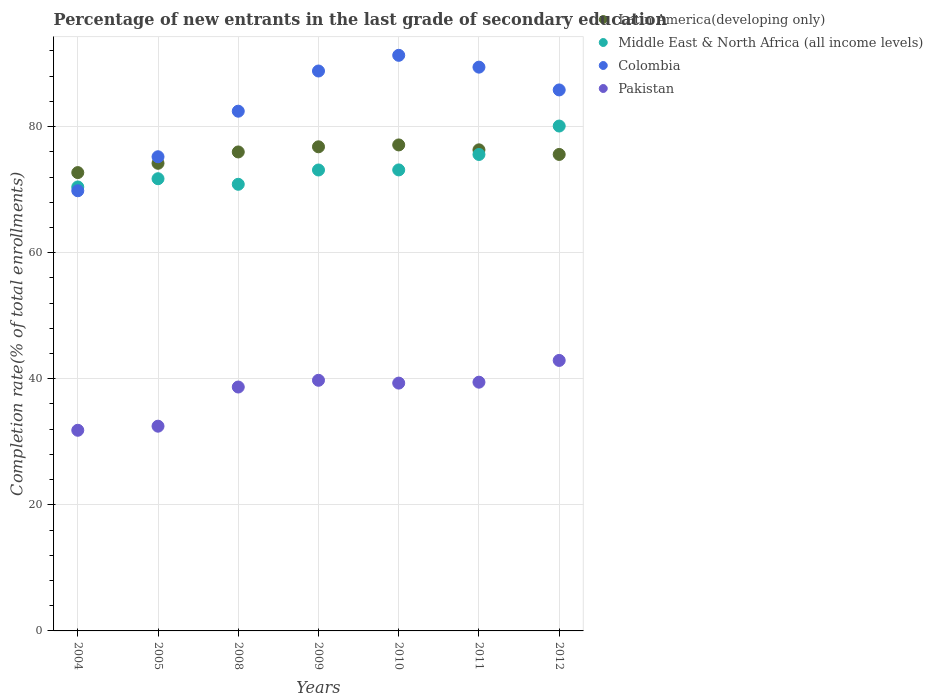How many different coloured dotlines are there?
Offer a very short reply. 4. Is the number of dotlines equal to the number of legend labels?
Keep it short and to the point. Yes. What is the percentage of new entrants in Latin America(developing only) in 2009?
Ensure brevity in your answer.  76.79. Across all years, what is the maximum percentage of new entrants in Middle East & North Africa (all income levels)?
Your response must be concise. 80.09. Across all years, what is the minimum percentage of new entrants in Colombia?
Offer a very short reply. 69.82. In which year was the percentage of new entrants in Latin America(developing only) maximum?
Keep it short and to the point. 2010. What is the total percentage of new entrants in Colombia in the graph?
Your answer should be very brief. 582.82. What is the difference between the percentage of new entrants in Colombia in 2005 and that in 2008?
Provide a short and direct response. -7.23. What is the difference between the percentage of new entrants in Colombia in 2009 and the percentage of new entrants in Middle East & North Africa (all income levels) in 2012?
Offer a very short reply. 8.73. What is the average percentage of new entrants in Colombia per year?
Provide a succinct answer. 83.26. In the year 2011, what is the difference between the percentage of new entrants in Latin America(developing only) and percentage of new entrants in Colombia?
Provide a short and direct response. -13.12. In how many years, is the percentage of new entrants in Colombia greater than 40 %?
Offer a terse response. 7. What is the ratio of the percentage of new entrants in Pakistan in 2004 to that in 2011?
Your answer should be very brief. 0.81. Is the percentage of new entrants in Pakistan in 2008 less than that in 2011?
Your response must be concise. Yes. Is the difference between the percentage of new entrants in Latin America(developing only) in 2008 and 2009 greater than the difference between the percentage of new entrants in Colombia in 2008 and 2009?
Keep it short and to the point. Yes. What is the difference between the highest and the second highest percentage of new entrants in Middle East & North Africa (all income levels)?
Offer a terse response. 4.51. What is the difference between the highest and the lowest percentage of new entrants in Colombia?
Ensure brevity in your answer.  21.48. Is the percentage of new entrants in Latin America(developing only) strictly greater than the percentage of new entrants in Colombia over the years?
Provide a succinct answer. No. Is the percentage of new entrants in Pakistan strictly less than the percentage of new entrants in Middle East & North Africa (all income levels) over the years?
Your response must be concise. Yes. How many dotlines are there?
Provide a succinct answer. 4. Does the graph contain grids?
Make the answer very short. Yes. How many legend labels are there?
Offer a very short reply. 4. What is the title of the graph?
Your response must be concise. Percentage of new entrants in the last grade of secondary education. What is the label or title of the Y-axis?
Your answer should be very brief. Completion rate(% of total enrollments). What is the Completion rate(% of total enrollments) of Latin America(developing only) in 2004?
Your answer should be compact. 72.7. What is the Completion rate(% of total enrollments) in Middle East & North Africa (all income levels) in 2004?
Make the answer very short. 70.42. What is the Completion rate(% of total enrollments) of Colombia in 2004?
Your answer should be very brief. 69.82. What is the Completion rate(% of total enrollments) of Pakistan in 2004?
Make the answer very short. 31.83. What is the Completion rate(% of total enrollments) of Latin America(developing only) in 2005?
Keep it short and to the point. 74.18. What is the Completion rate(% of total enrollments) in Middle East & North Africa (all income levels) in 2005?
Offer a very short reply. 71.73. What is the Completion rate(% of total enrollments) of Colombia in 2005?
Your answer should be very brief. 75.21. What is the Completion rate(% of total enrollments) in Pakistan in 2005?
Your answer should be very brief. 32.48. What is the Completion rate(% of total enrollments) of Latin America(developing only) in 2008?
Offer a terse response. 75.98. What is the Completion rate(% of total enrollments) in Middle East & North Africa (all income levels) in 2008?
Your response must be concise. 70.84. What is the Completion rate(% of total enrollments) in Colombia in 2008?
Provide a succinct answer. 82.44. What is the Completion rate(% of total enrollments) of Pakistan in 2008?
Your answer should be very brief. 38.69. What is the Completion rate(% of total enrollments) in Latin America(developing only) in 2009?
Provide a succinct answer. 76.79. What is the Completion rate(% of total enrollments) in Middle East & North Africa (all income levels) in 2009?
Your answer should be very brief. 73.11. What is the Completion rate(% of total enrollments) in Colombia in 2009?
Offer a terse response. 88.81. What is the Completion rate(% of total enrollments) of Pakistan in 2009?
Your answer should be very brief. 39.76. What is the Completion rate(% of total enrollments) of Latin America(developing only) in 2010?
Offer a very short reply. 77.09. What is the Completion rate(% of total enrollments) in Middle East & North Africa (all income levels) in 2010?
Your answer should be compact. 73.13. What is the Completion rate(% of total enrollments) in Colombia in 2010?
Provide a succinct answer. 91.3. What is the Completion rate(% of total enrollments) of Pakistan in 2010?
Offer a terse response. 39.31. What is the Completion rate(% of total enrollments) in Latin America(developing only) in 2011?
Your answer should be very brief. 76.31. What is the Completion rate(% of total enrollments) in Middle East & North Africa (all income levels) in 2011?
Provide a succinct answer. 75.57. What is the Completion rate(% of total enrollments) of Colombia in 2011?
Make the answer very short. 89.43. What is the Completion rate(% of total enrollments) of Pakistan in 2011?
Your response must be concise. 39.45. What is the Completion rate(% of total enrollments) of Latin America(developing only) in 2012?
Give a very brief answer. 75.58. What is the Completion rate(% of total enrollments) in Middle East & North Africa (all income levels) in 2012?
Offer a very short reply. 80.09. What is the Completion rate(% of total enrollments) of Colombia in 2012?
Your response must be concise. 85.81. What is the Completion rate(% of total enrollments) in Pakistan in 2012?
Give a very brief answer. 42.91. Across all years, what is the maximum Completion rate(% of total enrollments) of Latin America(developing only)?
Offer a terse response. 77.09. Across all years, what is the maximum Completion rate(% of total enrollments) of Middle East & North Africa (all income levels)?
Your answer should be compact. 80.09. Across all years, what is the maximum Completion rate(% of total enrollments) in Colombia?
Offer a terse response. 91.3. Across all years, what is the maximum Completion rate(% of total enrollments) of Pakistan?
Make the answer very short. 42.91. Across all years, what is the minimum Completion rate(% of total enrollments) of Latin America(developing only)?
Your response must be concise. 72.7. Across all years, what is the minimum Completion rate(% of total enrollments) in Middle East & North Africa (all income levels)?
Provide a succinct answer. 70.42. Across all years, what is the minimum Completion rate(% of total enrollments) of Colombia?
Ensure brevity in your answer.  69.82. Across all years, what is the minimum Completion rate(% of total enrollments) in Pakistan?
Offer a terse response. 31.83. What is the total Completion rate(% of total enrollments) of Latin America(developing only) in the graph?
Give a very brief answer. 528.62. What is the total Completion rate(% of total enrollments) of Middle East & North Africa (all income levels) in the graph?
Provide a short and direct response. 514.89. What is the total Completion rate(% of total enrollments) in Colombia in the graph?
Offer a terse response. 582.82. What is the total Completion rate(% of total enrollments) of Pakistan in the graph?
Your answer should be compact. 264.42. What is the difference between the Completion rate(% of total enrollments) of Latin America(developing only) in 2004 and that in 2005?
Ensure brevity in your answer.  -1.48. What is the difference between the Completion rate(% of total enrollments) of Middle East & North Africa (all income levels) in 2004 and that in 2005?
Keep it short and to the point. -1.31. What is the difference between the Completion rate(% of total enrollments) of Colombia in 2004 and that in 2005?
Your answer should be very brief. -5.39. What is the difference between the Completion rate(% of total enrollments) in Pakistan in 2004 and that in 2005?
Give a very brief answer. -0.65. What is the difference between the Completion rate(% of total enrollments) in Latin America(developing only) in 2004 and that in 2008?
Your response must be concise. -3.27. What is the difference between the Completion rate(% of total enrollments) in Middle East & North Africa (all income levels) in 2004 and that in 2008?
Provide a short and direct response. -0.42. What is the difference between the Completion rate(% of total enrollments) of Colombia in 2004 and that in 2008?
Ensure brevity in your answer.  -12.62. What is the difference between the Completion rate(% of total enrollments) in Pakistan in 2004 and that in 2008?
Offer a terse response. -6.86. What is the difference between the Completion rate(% of total enrollments) in Latin America(developing only) in 2004 and that in 2009?
Your answer should be very brief. -4.09. What is the difference between the Completion rate(% of total enrollments) of Middle East & North Africa (all income levels) in 2004 and that in 2009?
Give a very brief answer. -2.69. What is the difference between the Completion rate(% of total enrollments) of Colombia in 2004 and that in 2009?
Offer a very short reply. -18.99. What is the difference between the Completion rate(% of total enrollments) in Pakistan in 2004 and that in 2009?
Provide a short and direct response. -7.93. What is the difference between the Completion rate(% of total enrollments) of Latin America(developing only) in 2004 and that in 2010?
Your answer should be compact. -4.39. What is the difference between the Completion rate(% of total enrollments) of Middle East & North Africa (all income levels) in 2004 and that in 2010?
Offer a terse response. -2.7. What is the difference between the Completion rate(% of total enrollments) of Colombia in 2004 and that in 2010?
Offer a terse response. -21.48. What is the difference between the Completion rate(% of total enrollments) in Pakistan in 2004 and that in 2010?
Ensure brevity in your answer.  -7.48. What is the difference between the Completion rate(% of total enrollments) in Latin America(developing only) in 2004 and that in 2011?
Provide a short and direct response. -3.61. What is the difference between the Completion rate(% of total enrollments) of Middle East & North Africa (all income levels) in 2004 and that in 2011?
Your response must be concise. -5.15. What is the difference between the Completion rate(% of total enrollments) of Colombia in 2004 and that in 2011?
Your answer should be very brief. -19.61. What is the difference between the Completion rate(% of total enrollments) of Pakistan in 2004 and that in 2011?
Your answer should be very brief. -7.63. What is the difference between the Completion rate(% of total enrollments) of Latin America(developing only) in 2004 and that in 2012?
Ensure brevity in your answer.  -2.88. What is the difference between the Completion rate(% of total enrollments) in Middle East & North Africa (all income levels) in 2004 and that in 2012?
Keep it short and to the point. -9.66. What is the difference between the Completion rate(% of total enrollments) of Colombia in 2004 and that in 2012?
Your response must be concise. -15.99. What is the difference between the Completion rate(% of total enrollments) of Pakistan in 2004 and that in 2012?
Offer a very short reply. -11.08. What is the difference between the Completion rate(% of total enrollments) of Latin America(developing only) in 2005 and that in 2008?
Give a very brief answer. -1.8. What is the difference between the Completion rate(% of total enrollments) of Middle East & North Africa (all income levels) in 2005 and that in 2008?
Your response must be concise. 0.88. What is the difference between the Completion rate(% of total enrollments) in Colombia in 2005 and that in 2008?
Give a very brief answer. -7.23. What is the difference between the Completion rate(% of total enrollments) of Pakistan in 2005 and that in 2008?
Make the answer very short. -6.21. What is the difference between the Completion rate(% of total enrollments) of Latin America(developing only) in 2005 and that in 2009?
Offer a very short reply. -2.61. What is the difference between the Completion rate(% of total enrollments) in Middle East & North Africa (all income levels) in 2005 and that in 2009?
Your answer should be compact. -1.38. What is the difference between the Completion rate(% of total enrollments) in Colombia in 2005 and that in 2009?
Keep it short and to the point. -13.6. What is the difference between the Completion rate(% of total enrollments) in Pakistan in 2005 and that in 2009?
Provide a succinct answer. -7.28. What is the difference between the Completion rate(% of total enrollments) in Latin America(developing only) in 2005 and that in 2010?
Your answer should be compact. -2.91. What is the difference between the Completion rate(% of total enrollments) of Middle East & North Africa (all income levels) in 2005 and that in 2010?
Give a very brief answer. -1.4. What is the difference between the Completion rate(% of total enrollments) in Colombia in 2005 and that in 2010?
Your answer should be compact. -16.09. What is the difference between the Completion rate(% of total enrollments) in Pakistan in 2005 and that in 2010?
Your answer should be very brief. -6.83. What is the difference between the Completion rate(% of total enrollments) of Latin America(developing only) in 2005 and that in 2011?
Your response must be concise. -2.13. What is the difference between the Completion rate(% of total enrollments) of Middle East & North Africa (all income levels) in 2005 and that in 2011?
Provide a short and direct response. -3.85. What is the difference between the Completion rate(% of total enrollments) in Colombia in 2005 and that in 2011?
Your response must be concise. -14.21. What is the difference between the Completion rate(% of total enrollments) in Pakistan in 2005 and that in 2011?
Provide a succinct answer. -6.98. What is the difference between the Completion rate(% of total enrollments) of Latin America(developing only) in 2005 and that in 2012?
Your answer should be very brief. -1.41. What is the difference between the Completion rate(% of total enrollments) of Middle East & North Africa (all income levels) in 2005 and that in 2012?
Give a very brief answer. -8.36. What is the difference between the Completion rate(% of total enrollments) of Colombia in 2005 and that in 2012?
Make the answer very short. -10.6. What is the difference between the Completion rate(% of total enrollments) of Pakistan in 2005 and that in 2012?
Your answer should be compact. -10.43. What is the difference between the Completion rate(% of total enrollments) of Latin America(developing only) in 2008 and that in 2009?
Ensure brevity in your answer.  -0.82. What is the difference between the Completion rate(% of total enrollments) of Middle East & North Africa (all income levels) in 2008 and that in 2009?
Offer a very short reply. -2.27. What is the difference between the Completion rate(% of total enrollments) of Colombia in 2008 and that in 2009?
Offer a terse response. -6.37. What is the difference between the Completion rate(% of total enrollments) of Pakistan in 2008 and that in 2009?
Offer a terse response. -1.07. What is the difference between the Completion rate(% of total enrollments) of Latin America(developing only) in 2008 and that in 2010?
Give a very brief answer. -1.11. What is the difference between the Completion rate(% of total enrollments) of Middle East & North Africa (all income levels) in 2008 and that in 2010?
Offer a very short reply. -2.28. What is the difference between the Completion rate(% of total enrollments) of Colombia in 2008 and that in 2010?
Provide a succinct answer. -8.86. What is the difference between the Completion rate(% of total enrollments) of Pakistan in 2008 and that in 2010?
Your response must be concise. -0.62. What is the difference between the Completion rate(% of total enrollments) in Latin America(developing only) in 2008 and that in 2011?
Provide a succinct answer. -0.34. What is the difference between the Completion rate(% of total enrollments) in Middle East & North Africa (all income levels) in 2008 and that in 2011?
Provide a short and direct response. -4.73. What is the difference between the Completion rate(% of total enrollments) in Colombia in 2008 and that in 2011?
Ensure brevity in your answer.  -6.99. What is the difference between the Completion rate(% of total enrollments) of Pakistan in 2008 and that in 2011?
Offer a terse response. -0.77. What is the difference between the Completion rate(% of total enrollments) of Latin America(developing only) in 2008 and that in 2012?
Your answer should be compact. 0.39. What is the difference between the Completion rate(% of total enrollments) in Middle East & North Africa (all income levels) in 2008 and that in 2012?
Make the answer very short. -9.24. What is the difference between the Completion rate(% of total enrollments) of Colombia in 2008 and that in 2012?
Keep it short and to the point. -3.37. What is the difference between the Completion rate(% of total enrollments) of Pakistan in 2008 and that in 2012?
Make the answer very short. -4.22. What is the difference between the Completion rate(% of total enrollments) of Latin America(developing only) in 2009 and that in 2010?
Keep it short and to the point. -0.3. What is the difference between the Completion rate(% of total enrollments) of Middle East & North Africa (all income levels) in 2009 and that in 2010?
Offer a terse response. -0.01. What is the difference between the Completion rate(% of total enrollments) of Colombia in 2009 and that in 2010?
Keep it short and to the point. -2.49. What is the difference between the Completion rate(% of total enrollments) of Pakistan in 2009 and that in 2010?
Provide a succinct answer. 0.45. What is the difference between the Completion rate(% of total enrollments) of Latin America(developing only) in 2009 and that in 2011?
Ensure brevity in your answer.  0.48. What is the difference between the Completion rate(% of total enrollments) of Middle East & North Africa (all income levels) in 2009 and that in 2011?
Offer a terse response. -2.46. What is the difference between the Completion rate(% of total enrollments) of Colombia in 2009 and that in 2011?
Your response must be concise. -0.61. What is the difference between the Completion rate(% of total enrollments) in Pakistan in 2009 and that in 2011?
Your answer should be very brief. 0.3. What is the difference between the Completion rate(% of total enrollments) in Latin America(developing only) in 2009 and that in 2012?
Your answer should be very brief. 1.21. What is the difference between the Completion rate(% of total enrollments) in Middle East & North Africa (all income levels) in 2009 and that in 2012?
Provide a short and direct response. -6.97. What is the difference between the Completion rate(% of total enrollments) of Colombia in 2009 and that in 2012?
Provide a succinct answer. 3. What is the difference between the Completion rate(% of total enrollments) of Pakistan in 2009 and that in 2012?
Your answer should be compact. -3.15. What is the difference between the Completion rate(% of total enrollments) in Latin America(developing only) in 2010 and that in 2011?
Make the answer very short. 0.78. What is the difference between the Completion rate(% of total enrollments) of Middle East & North Africa (all income levels) in 2010 and that in 2011?
Offer a terse response. -2.45. What is the difference between the Completion rate(% of total enrollments) in Colombia in 2010 and that in 2011?
Make the answer very short. 1.88. What is the difference between the Completion rate(% of total enrollments) of Pakistan in 2010 and that in 2011?
Make the answer very short. -0.14. What is the difference between the Completion rate(% of total enrollments) of Latin America(developing only) in 2010 and that in 2012?
Make the answer very short. 1.51. What is the difference between the Completion rate(% of total enrollments) in Middle East & North Africa (all income levels) in 2010 and that in 2012?
Provide a short and direct response. -6.96. What is the difference between the Completion rate(% of total enrollments) in Colombia in 2010 and that in 2012?
Your response must be concise. 5.49. What is the difference between the Completion rate(% of total enrollments) in Pakistan in 2010 and that in 2012?
Keep it short and to the point. -3.6. What is the difference between the Completion rate(% of total enrollments) of Latin America(developing only) in 2011 and that in 2012?
Offer a terse response. 0.73. What is the difference between the Completion rate(% of total enrollments) of Middle East & North Africa (all income levels) in 2011 and that in 2012?
Your answer should be compact. -4.51. What is the difference between the Completion rate(% of total enrollments) of Colombia in 2011 and that in 2012?
Offer a very short reply. 3.61. What is the difference between the Completion rate(% of total enrollments) of Pakistan in 2011 and that in 2012?
Offer a terse response. -3.45. What is the difference between the Completion rate(% of total enrollments) in Latin America(developing only) in 2004 and the Completion rate(% of total enrollments) in Middle East & North Africa (all income levels) in 2005?
Offer a terse response. 0.97. What is the difference between the Completion rate(% of total enrollments) in Latin America(developing only) in 2004 and the Completion rate(% of total enrollments) in Colombia in 2005?
Give a very brief answer. -2.51. What is the difference between the Completion rate(% of total enrollments) of Latin America(developing only) in 2004 and the Completion rate(% of total enrollments) of Pakistan in 2005?
Your response must be concise. 40.22. What is the difference between the Completion rate(% of total enrollments) of Middle East & North Africa (all income levels) in 2004 and the Completion rate(% of total enrollments) of Colombia in 2005?
Give a very brief answer. -4.79. What is the difference between the Completion rate(% of total enrollments) of Middle East & North Africa (all income levels) in 2004 and the Completion rate(% of total enrollments) of Pakistan in 2005?
Your response must be concise. 37.95. What is the difference between the Completion rate(% of total enrollments) in Colombia in 2004 and the Completion rate(% of total enrollments) in Pakistan in 2005?
Ensure brevity in your answer.  37.34. What is the difference between the Completion rate(% of total enrollments) in Latin America(developing only) in 2004 and the Completion rate(% of total enrollments) in Middle East & North Africa (all income levels) in 2008?
Keep it short and to the point. 1.86. What is the difference between the Completion rate(% of total enrollments) in Latin America(developing only) in 2004 and the Completion rate(% of total enrollments) in Colombia in 2008?
Provide a short and direct response. -9.74. What is the difference between the Completion rate(% of total enrollments) in Latin America(developing only) in 2004 and the Completion rate(% of total enrollments) in Pakistan in 2008?
Ensure brevity in your answer.  34.01. What is the difference between the Completion rate(% of total enrollments) of Middle East & North Africa (all income levels) in 2004 and the Completion rate(% of total enrollments) of Colombia in 2008?
Provide a succinct answer. -12.02. What is the difference between the Completion rate(% of total enrollments) of Middle East & North Africa (all income levels) in 2004 and the Completion rate(% of total enrollments) of Pakistan in 2008?
Ensure brevity in your answer.  31.73. What is the difference between the Completion rate(% of total enrollments) of Colombia in 2004 and the Completion rate(% of total enrollments) of Pakistan in 2008?
Give a very brief answer. 31.13. What is the difference between the Completion rate(% of total enrollments) of Latin America(developing only) in 2004 and the Completion rate(% of total enrollments) of Middle East & North Africa (all income levels) in 2009?
Offer a terse response. -0.41. What is the difference between the Completion rate(% of total enrollments) of Latin America(developing only) in 2004 and the Completion rate(% of total enrollments) of Colombia in 2009?
Offer a terse response. -16.11. What is the difference between the Completion rate(% of total enrollments) in Latin America(developing only) in 2004 and the Completion rate(% of total enrollments) in Pakistan in 2009?
Keep it short and to the point. 32.94. What is the difference between the Completion rate(% of total enrollments) of Middle East & North Africa (all income levels) in 2004 and the Completion rate(% of total enrollments) of Colombia in 2009?
Your answer should be compact. -18.39. What is the difference between the Completion rate(% of total enrollments) of Middle East & North Africa (all income levels) in 2004 and the Completion rate(% of total enrollments) of Pakistan in 2009?
Make the answer very short. 30.66. What is the difference between the Completion rate(% of total enrollments) of Colombia in 2004 and the Completion rate(% of total enrollments) of Pakistan in 2009?
Your answer should be compact. 30.06. What is the difference between the Completion rate(% of total enrollments) in Latin America(developing only) in 2004 and the Completion rate(% of total enrollments) in Middle East & North Africa (all income levels) in 2010?
Your answer should be very brief. -0.42. What is the difference between the Completion rate(% of total enrollments) of Latin America(developing only) in 2004 and the Completion rate(% of total enrollments) of Colombia in 2010?
Give a very brief answer. -18.6. What is the difference between the Completion rate(% of total enrollments) of Latin America(developing only) in 2004 and the Completion rate(% of total enrollments) of Pakistan in 2010?
Offer a very short reply. 33.39. What is the difference between the Completion rate(% of total enrollments) of Middle East & North Africa (all income levels) in 2004 and the Completion rate(% of total enrollments) of Colombia in 2010?
Keep it short and to the point. -20.88. What is the difference between the Completion rate(% of total enrollments) of Middle East & North Africa (all income levels) in 2004 and the Completion rate(% of total enrollments) of Pakistan in 2010?
Offer a very short reply. 31.11. What is the difference between the Completion rate(% of total enrollments) of Colombia in 2004 and the Completion rate(% of total enrollments) of Pakistan in 2010?
Provide a short and direct response. 30.51. What is the difference between the Completion rate(% of total enrollments) in Latin America(developing only) in 2004 and the Completion rate(% of total enrollments) in Middle East & North Africa (all income levels) in 2011?
Keep it short and to the point. -2.87. What is the difference between the Completion rate(% of total enrollments) of Latin America(developing only) in 2004 and the Completion rate(% of total enrollments) of Colombia in 2011?
Offer a terse response. -16.73. What is the difference between the Completion rate(% of total enrollments) of Latin America(developing only) in 2004 and the Completion rate(% of total enrollments) of Pakistan in 2011?
Your response must be concise. 33.25. What is the difference between the Completion rate(% of total enrollments) in Middle East & North Africa (all income levels) in 2004 and the Completion rate(% of total enrollments) in Colombia in 2011?
Your answer should be very brief. -19. What is the difference between the Completion rate(% of total enrollments) of Middle East & North Africa (all income levels) in 2004 and the Completion rate(% of total enrollments) of Pakistan in 2011?
Make the answer very short. 30.97. What is the difference between the Completion rate(% of total enrollments) in Colombia in 2004 and the Completion rate(% of total enrollments) in Pakistan in 2011?
Provide a succinct answer. 30.36. What is the difference between the Completion rate(% of total enrollments) in Latin America(developing only) in 2004 and the Completion rate(% of total enrollments) in Middle East & North Africa (all income levels) in 2012?
Keep it short and to the point. -7.38. What is the difference between the Completion rate(% of total enrollments) of Latin America(developing only) in 2004 and the Completion rate(% of total enrollments) of Colombia in 2012?
Provide a short and direct response. -13.11. What is the difference between the Completion rate(% of total enrollments) in Latin America(developing only) in 2004 and the Completion rate(% of total enrollments) in Pakistan in 2012?
Make the answer very short. 29.79. What is the difference between the Completion rate(% of total enrollments) in Middle East & North Africa (all income levels) in 2004 and the Completion rate(% of total enrollments) in Colombia in 2012?
Offer a very short reply. -15.39. What is the difference between the Completion rate(% of total enrollments) of Middle East & North Africa (all income levels) in 2004 and the Completion rate(% of total enrollments) of Pakistan in 2012?
Provide a short and direct response. 27.52. What is the difference between the Completion rate(% of total enrollments) in Colombia in 2004 and the Completion rate(% of total enrollments) in Pakistan in 2012?
Give a very brief answer. 26.91. What is the difference between the Completion rate(% of total enrollments) of Latin America(developing only) in 2005 and the Completion rate(% of total enrollments) of Middle East & North Africa (all income levels) in 2008?
Your response must be concise. 3.33. What is the difference between the Completion rate(% of total enrollments) of Latin America(developing only) in 2005 and the Completion rate(% of total enrollments) of Colombia in 2008?
Offer a very short reply. -8.26. What is the difference between the Completion rate(% of total enrollments) of Latin America(developing only) in 2005 and the Completion rate(% of total enrollments) of Pakistan in 2008?
Provide a short and direct response. 35.49. What is the difference between the Completion rate(% of total enrollments) in Middle East & North Africa (all income levels) in 2005 and the Completion rate(% of total enrollments) in Colombia in 2008?
Offer a terse response. -10.71. What is the difference between the Completion rate(% of total enrollments) of Middle East & North Africa (all income levels) in 2005 and the Completion rate(% of total enrollments) of Pakistan in 2008?
Provide a succinct answer. 33.04. What is the difference between the Completion rate(% of total enrollments) in Colombia in 2005 and the Completion rate(% of total enrollments) in Pakistan in 2008?
Your answer should be very brief. 36.52. What is the difference between the Completion rate(% of total enrollments) in Latin America(developing only) in 2005 and the Completion rate(% of total enrollments) in Middle East & North Africa (all income levels) in 2009?
Keep it short and to the point. 1.06. What is the difference between the Completion rate(% of total enrollments) of Latin America(developing only) in 2005 and the Completion rate(% of total enrollments) of Colombia in 2009?
Ensure brevity in your answer.  -14.64. What is the difference between the Completion rate(% of total enrollments) in Latin America(developing only) in 2005 and the Completion rate(% of total enrollments) in Pakistan in 2009?
Provide a succinct answer. 34.42. What is the difference between the Completion rate(% of total enrollments) in Middle East & North Africa (all income levels) in 2005 and the Completion rate(% of total enrollments) in Colombia in 2009?
Provide a succinct answer. -17.09. What is the difference between the Completion rate(% of total enrollments) in Middle East & North Africa (all income levels) in 2005 and the Completion rate(% of total enrollments) in Pakistan in 2009?
Offer a very short reply. 31.97. What is the difference between the Completion rate(% of total enrollments) of Colombia in 2005 and the Completion rate(% of total enrollments) of Pakistan in 2009?
Offer a very short reply. 35.46. What is the difference between the Completion rate(% of total enrollments) of Latin America(developing only) in 2005 and the Completion rate(% of total enrollments) of Middle East & North Africa (all income levels) in 2010?
Provide a short and direct response. 1.05. What is the difference between the Completion rate(% of total enrollments) of Latin America(developing only) in 2005 and the Completion rate(% of total enrollments) of Colombia in 2010?
Offer a terse response. -17.13. What is the difference between the Completion rate(% of total enrollments) in Latin America(developing only) in 2005 and the Completion rate(% of total enrollments) in Pakistan in 2010?
Your response must be concise. 34.87. What is the difference between the Completion rate(% of total enrollments) of Middle East & North Africa (all income levels) in 2005 and the Completion rate(% of total enrollments) of Colombia in 2010?
Ensure brevity in your answer.  -19.57. What is the difference between the Completion rate(% of total enrollments) in Middle East & North Africa (all income levels) in 2005 and the Completion rate(% of total enrollments) in Pakistan in 2010?
Your answer should be compact. 32.42. What is the difference between the Completion rate(% of total enrollments) in Colombia in 2005 and the Completion rate(% of total enrollments) in Pakistan in 2010?
Your response must be concise. 35.9. What is the difference between the Completion rate(% of total enrollments) in Latin America(developing only) in 2005 and the Completion rate(% of total enrollments) in Middle East & North Africa (all income levels) in 2011?
Offer a very short reply. -1.4. What is the difference between the Completion rate(% of total enrollments) of Latin America(developing only) in 2005 and the Completion rate(% of total enrollments) of Colombia in 2011?
Ensure brevity in your answer.  -15.25. What is the difference between the Completion rate(% of total enrollments) in Latin America(developing only) in 2005 and the Completion rate(% of total enrollments) in Pakistan in 2011?
Provide a succinct answer. 34.72. What is the difference between the Completion rate(% of total enrollments) in Middle East & North Africa (all income levels) in 2005 and the Completion rate(% of total enrollments) in Colombia in 2011?
Ensure brevity in your answer.  -17.7. What is the difference between the Completion rate(% of total enrollments) of Middle East & North Africa (all income levels) in 2005 and the Completion rate(% of total enrollments) of Pakistan in 2011?
Make the answer very short. 32.27. What is the difference between the Completion rate(% of total enrollments) in Colombia in 2005 and the Completion rate(% of total enrollments) in Pakistan in 2011?
Give a very brief answer. 35.76. What is the difference between the Completion rate(% of total enrollments) in Latin America(developing only) in 2005 and the Completion rate(% of total enrollments) in Middle East & North Africa (all income levels) in 2012?
Offer a very short reply. -5.91. What is the difference between the Completion rate(% of total enrollments) in Latin America(developing only) in 2005 and the Completion rate(% of total enrollments) in Colombia in 2012?
Make the answer very short. -11.64. What is the difference between the Completion rate(% of total enrollments) of Latin America(developing only) in 2005 and the Completion rate(% of total enrollments) of Pakistan in 2012?
Offer a very short reply. 31.27. What is the difference between the Completion rate(% of total enrollments) of Middle East & North Africa (all income levels) in 2005 and the Completion rate(% of total enrollments) of Colombia in 2012?
Make the answer very short. -14.08. What is the difference between the Completion rate(% of total enrollments) in Middle East & North Africa (all income levels) in 2005 and the Completion rate(% of total enrollments) in Pakistan in 2012?
Offer a terse response. 28.82. What is the difference between the Completion rate(% of total enrollments) in Colombia in 2005 and the Completion rate(% of total enrollments) in Pakistan in 2012?
Your answer should be compact. 32.31. What is the difference between the Completion rate(% of total enrollments) of Latin America(developing only) in 2008 and the Completion rate(% of total enrollments) of Middle East & North Africa (all income levels) in 2009?
Keep it short and to the point. 2.86. What is the difference between the Completion rate(% of total enrollments) of Latin America(developing only) in 2008 and the Completion rate(% of total enrollments) of Colombia in 2009?
Offer a terse response. -12.84. What is the difference between the Completion rate(% of total enrollments) in Latin America(developing only) in 2008 and the Completion rate(% of total enrollments) in Pakistan in 2009?
Provide a short and direct response. 36.22. What is the difference between the Completion rate(% of total enrollments) in Middle East & North Africa (all income levels) in 2008 and the Completion rate(% of total enrollments) in Colombia in 2009?
Make the answer very short. -17.97. What is the difference between the Completion rate(% of total enrollments) in Middle East & North Africa (all income levels) in 2008 and the Completion rate(% of total enrollments) in Pakistan in 2009?
Keep it short and to the point. 31.09. What is the difference between the Completion rate(% of total enrollments) of Colombia in 2008 and the Completion rate(% of total enrollments) of Pakistan in 2009?
Your answer should be very brief. 42.68. What is the difference between the Completion rate(% of total enrollments) in Latin America(developing only) in 2008 and the Completion rate(% of total enrollments) in Middle East & North Africa (all income levels) in 2010?
Offer a very short reply. 2.85. What is the difference between the Completion rate(% of total enrollments) of Latin America(developing only) in 2008 and the Completion rate(% of total enrollments) of Colombia in 2010?
Give a very brief answer. -15.33. What is the difference between the Completion rate(% of total enrollments) in Latin America(developing only) in 2008 and the Completion rate(% of total enrollments) in Pakistan in 2010?
Offer a terse response. 36.67. What is the difference between the Completion rate(% of total enrollments) of Middle East & North Africa (all income levels) in 2008 and the Completion rate(% of total enrollments) of Colombia in 2010?
Keep it short and to the point. -20.46. What is the difference between the Completion rate(% of total enrollments) in Middle East & North Africa (all income levels) in 2008 and the Completion rate(% of total enrollments) in Pakistan in 2010?
Your response must be concise. 31.53. What is the difference between the Completion rate(% of total enrollments) in Colombia in 2008 and the Completion rate(% of total enrollments) in Pakistan in 2010?
Offer a terse response. 43.13. What is the difference between the Completion rate(% of total enrollments) in Latin America(developing only) in 2008 and the Completion rate(% of total enrollments) in Middle East & North Africa (all income levels) in 2011?
Provide a short and direct response. 0.4. What is the difference between the Completion rate(% of total enrollments) in Latin America(developing only) in 2008 and the Completion rate(% of total enrollments) in Colombia in 2011?
Make the answer very short. -13.45. What is the difference between the Completion rate(% of total enrollments) in Latin America(developing only) in 2008 and the Completion rate(% of total enrollments) in Pakistan in 2011?
Ensure brevity in your answer.  36.52. What is the difference between the Completion rate(% of total enrollments) of Middle East & North Africa (all income levels) in 2008 and the Completion rate(% of total enrollments) of Colombia in 2011?
Your answer should be very brief. -18.58. What is the difference between the Completion rate(% of total enrollments) of Middle East & North Africa (all income levels) in 2008 and the Completion rate(% of total enrollments) of Pakistan in 2011?
Offer a terse response. 31.39. What is the difference between the Completion rate(% of total enrollments) of Colombia in 2008 and the Completion rate(% of total enrollments) of Pakistan in 2011?
Offer a terse response. 42.98. What is the difference between the Completion rate(% of total enrollments) of Latin America(developing only) in 2008 and the Completion rate(% of total enrollments) of Middle East & North Africa (all income levels) in 2012?
Give a very brief answer. -4.11. What is the difference between the Completion rate(% of total enrollments) in Latin America(developing only) in 2008 and the Completion rate(% of total enrollments) in Colombia in 2012?
Provide a short and direct response. -9.84. What is the difference between the Completion rate(% of total enrollments) in Latin America(developing only) in 2008 and the Completion rate(% of total enrollments) in Pakistan in 2012?
Ensure brevity in your answer.  33.07. What is the difference between the Completion rate(% of total enrollments) of Middle East & North Africa (all income levels) in 2008 and the Completion rate(% of total enrollments) of Colombia in 2012?
Offer a very short reply. -14.97. What is the difference between the Completion rate(% of total enrollments) of Middle East & North Africa (all income levels) in 2008 and the Completion rate(% of total enrollments) of Pakistan in 2012?
Offer a very short reply. 27.94. What is the difference between the Completion rate(% of total enrollments) in Colombia in 2008 and the Completion rate(% of total enrollments) in Pakistan in 2012?
Give a very brief answer. 39.53. What is the difference between the Completion rate(% of total enrollments) in Latin America(developing only) in 2009 and the Completion rate(% of total enrollments) in Middle East & North Africa (all income levels) in 2010?
Your response must be concise. 3.66. What is the difference between the Completion rate(% of total enrollments) of Latin America(developing only) in 2009 and the Completion rate(% of total enrollments) of Colombia in 2010?
Your answer should be very brief. -14.51. What is the difference between the Completion rate(% of total enrollments) of Latin America(developing only) in 2009 and the Completion rate(% of total enrollments) of Pakistan in 2010?
Offer a terse response. 37.48. What is the difference between the Completion rate(% of total enrollments) of Middle East & North Africa (all income levels) in 2009 and the Completion rate(% of total enrollments) of Colombia in 2010?
Give a very brief answer. -18.19. What is the difference between the Completion rate(% of total enrollments) of Middle East & North Africa (all income levels) in 2009 and the Completion rate(% of total enrollments) of Pakistan in 2010?
Your answer should be compact. 33.8. What is the difference between the Completion rate(% of total enrollments) in Colombia in 2009 and the Completion rate(% of total enrollments) in Pakistan in 2010?
Your response must be concise. 49.5. What is the difference between the Completion rate(% of total enrollments) in Latin America(developing only) in 2009 and the Completion rate(% of total enrollments) in Middle East & North Africa (all income levels) in 2011?
Provide a succinct answer. 1.22. What is the difference between the Completion rate(% of total enrollments) of Latin America(developing only) in 2009 and the Completion rate(% of total enrollments) of Colombia in 2011?
Make the answer very short. -12.64. What is the difference between the Completion rate(% of total enrollments) of Latin America(developing only) in 2009 and the Completion rate(% of total enrollments) of Pakistan in 2011?
Offer a very short reply. 37.34. What is the difference between the Completion rate(% of total enrollments) in Middle East & North Africa (all income levels) in 2009 and the Completion rate(% of total enrollments) in Colombia in 2011?
Your answer should be compact. -16.31. What is the difference between the Completion rate(% of total enrollments) of Middle East & North Africa (all income levels) in 2009 and the Completion rate(% of total enrollments) of Pakistan in 2011?
Your response must be concise. 33.66. What is the difference between the Completion rate(% of total enrollments) in Colombia in 2009 and the Completion rate(% of total enrollments) in Pakistan in 2011?
Your answer should be compact. 49.36. What is the difference between the Completion rate(% of total enrollments) of Latin America(developing only) in 2009 and the Completion rate(% of total enrollments) of Middle East & North Africa (all income levels) in 2012?
Your response must be concise. -3.3. What is the difference between the Completion rate(% of total enrollments) in Latin America(developing only) in 2009 and the Completion rate(% of total enrollments) in Colombia in 2012?
Your answer should be compact. -9.02. What is the difference between the Completion rate(% of total enrollments) of Latin America(developing only) in 2009 and the Completion rate(% of total enrollments) of Pakistan in 2012?
Make the answer very short. 33.88. What is the difference between the Completion rate(% of total enrollments) in Middle East & North Africa (all income levels) in 2009 and the Completion rate(% of total enrollments) in Colombia in 2012?
Your response must be concise. -12.7. What is the difference between the Completion rate(% of total enrollments) of Middle East & North Africa (all income levels) in 2009 and the Completion rate(% of total enrollments) of Pakistan in 2012?
Your answer should be very brief. 30.21. What is the difference between the Completion rate(% of total enrollments) in Colombia in 2009 and the Completion rate(% of total enrollments) in Pakistan in 2012?
Give a very brief answer. 45.91. What is the difference between the Completion rate(% of total enrollments) of Latin America(developing only) in 2010 and the Completion rate(% of total enrollments) of Middle East & North Africa (all income levels) in 2011?
Give a very brief answer. 1.51. What is the difference between the Completion rate(% of total enrollments) in Latin America(developing only) in 2010 and the Completion rate(% of total enrollments) in Colombia in 2011?
Your answer should be very brief. -12.34. What is the difference between the Completion rate(% of total enrollments) in Latin America(developing only) in 2010 and the Completion rate(% of total enrollments) in Pakistan in 2011?
Your answer should be very brief. 37.63. What is the difference between the Completion rate(% of total enrollments) of Middle East & North Africa (all income levels) in 2010 and the Completion rate(% of total enrollments) of Colombia in 2011?
Your response must be concise. -16.3. What is the difference between the Completion rate(% of total enrollments) of Middle East & North Africa (all income levels) in 2010 and the Completion rate(% of total enrollments) of Pakistan in 2011?
Your response must be concise. 33.67. What is the difference between the Completion rate(% of total enrollments) of Colombia in 2010 and the Completion rate(% of total enrollments) of Pakistan in 2011?
Give a very brief answer. 51.85. What is the difference between the Completion rate(% of total enrollments) in Latin America(developing only) in 2010 and the Completion rate(% of total enrollments) in Middle East & North Africa (all income levels) in 2012?
Keep it short and to the point. -3. What is the difference between the Completion rate(% of total enrollments) in Latin America(developing only) in 2010 and the Completion rate(% of total enrollments) in Colombia in 2012?
Your response must be concise. -8.72. What is the difference between the Completion rate(% of total enrollments) in Latin America(developing only) in 2010 and the Completion rate(% of total enrollments) in Pakistan in 2012?
Provide a short and direct response. 34.18. What is the difference between the Completion rate(% of total enrollments) of Middle East & North Africa (all income levels) in 2010 and the Completion rate(% of total enrollments) of Colombia in 2012?
Offer a terse response. -12.69. What is the difference between the Completion rate(% of total enrollments) in Middle East & North Africa (all income levels) in 2010 and the Completion rate(% of total enrollments) in Pakistan in 2012?
Provide a short and direct response. 30.22. What is the difference between the Completion rate(% of total enrollments) of Colombia in 2010 and the Completion rate(% of total enrollments) of Pakistan in 2012?
Give a very brief answer. 48.4. What is the difference between the Completion rate(% of total enrollments) of Latin America(developing only) in 2011 and the Completion rate(% of total enrollments) of Middle East & North Africa (all income levels) in 2012?
Keep it short and to the point. -3.78. What is the difference between the Completion rate(% of total enrollments) of Latin America(developing only) in 2011 and the Completion rate(% of total enrollments) of Colombia in 2012?
Your response must be concise. -9.5. What is the difference between the Completion rate(% of total enrollments) in Latin America(developing only) in 2011 and the Completion rate(% of total enrollments) in Pakistan in 2012?
Your response must be concise. 33.4. What is the difference between the Completion rate(% of total enrollments) of Middle East & North Africa (all income levels) in 2011 and the Completion rate(% of total enrollments) of Colombia in 2012?
Make the answer very short. -10.24. What is the difference between the Completion rate(% of total enrollments) of Middle East & North Africa (all income levels) in 2011 and the Completion rate(% of total enrollments) of Pakistan in 2012?
Offer a terse response. 32.67. What is the difference between the Completion rate(% of total enrollments) of Colombia in 2011 and the Completion rate(% of total enrollments) of Pakistan in 2012?
Offer a very short reply. 46.52. What is the average Completion rate(% of total enrollments) in Latin America(developing only) per year?
Provide a succinct answer. 75.52. What is the average Completion rate(% of total enrollments) of Middle East & North Africa (all income levels) per year?
Make the answer very short. 73.56. What is the average Completion rate(% of total enrollments) of Colombia per year?
Ensure brevity in your answer.  83.26. What is the average Completion rate(% of total enrollments) of Pakistan per year?
Keep it short and to the point. 37.77. In the year 2004, what is the difference between the Completion rate(% of total enrollments) of Latin America(developing only) and Completion rate(% of total enrollments) of Middle East & North Africa (all income levels)?
Keep it short and to the point. 2.28. In the year 2004, what is the difference between the Completion rate(% of total enrollments) of Latin America(developing only) and Completion rate(% of total enrollments) of Colombia?
Ensure brevity in your answer.  2.88. In the year 2004, what is the difference between the Completion rate(% of total enrollments) in Latin America(developing only) and Completion rate(% of total enrollments) in Pakistan?
Your answer should be compact. 40.87. In the year 2004, what is the difference between the Completion rate(% of total enrollments) in Middle East & North Africa (all income levels) and Completion rate(% of total enrollments) in Colombia?
Your response must be concise. 0.6. In the year 2004, what is the difference between the Completion rate(% of total enrollments) in Middle East & North Africa (all income levels) and Completion rate(% of total enrollments) in Pakistan?
Ensure brevity in your answer.  38.59. In the year 2004, what is the difference between the Completion rate(% of total enrollments) in Colombia and Completion rate(% of total enrollments) in Pakistan?
Provide a succinct answer. 37.99. In the year 2005, what is the difference between the Completion rate(% of total enrollments) of Latin America(developing only) and Completion rate(% of total enrollments) of Middle East & North Africa (all income levels)?
Offer a terse response. 2.45. In the year 2005, what is the difference between the Completion rate(% of total enrollments) in Latin America(developing only) and Completion rate(% of total enrollments) in Colombia?
Your response must be concise. -1.04. In the year 2005, what is the difference between the Completion rate(% of total enrollments) of Latin America(developing only) and Completion rate(% of total enrollments) of Pakistan?
Offer a very short reply. 41.7. In the year 2005, what is the difference between the Completion rate(% of total enrollments) in Middle East & North Africa (all income levels) and Completion rate(% of total enrollments) in Colombia?
Your answer should be compact. -3.48. In the year 2005, what is the difference between the Completion rate(% of total enrollments) in Middle East & North Africa (all income levels) and Completion rate(% of total enrollments) in Pakistan?
Make the answer very short. 39.25. In the year 2005, what is the difference between the Completion rate(% of total enrollments) of Colombia and Completion rate(% of total enrollments) of Pakistan?
Your answer should be compact. 42.74. In the year 2008, what is the difference between the Completion rate(% of total enrollments) of Latin America(developing only) and Completion rate(% of total enrollments) of Middle East & North Africa (all income levels)?
Your answer should be very brief. 5.13. In the year 2008, what is the difference between the Completion rate(% of total enrollments) in Latin America(developing only) and Completion rate(% of total enrollments) in Colombia?
Your answer should be compact. -6.46. In the year 2008, what is the difference between the Completion rate(% of total enrollments) of Latin America(developing only) and Completion rate(% of total enrollments) of Pakistan?
Offer a terse response. 37.29. In the year 2008, what is the difference between the Completion rate(% of total enrollments) of Middle East & North Africa (all income levels) and Completion rate(% of total enrollments) of Colombia?
Keep it short and to the point. -11.59. In the year 2008, what is the difference between the Completion rate(% of total enrollments) in Middle East & North Africa (all income levels) and Completion rate(% of total enrollments) in Pakistan?
Offer a terse response. 32.16. In the year 2008, what is the difference between the Completion rate(% of total enrollments) of Colombia and Completion rate(% of total enrollments) of Pakistan?
Ensure brevity in your answer.  43.75. In the year 2009, what is the difference between the Completion rate(% of total enrollments) of Latin America(developing only) and Completion rate(% of total enrollments) of Middle East & North Africa (all income levels)?
Offer a very short reply. 3.68. In the year 2009, what is the difference between the Completion rate(% of total enrollments) in Latin America(developing only) and Completion rate(% of total enrollments) in Colombia?
Your response must be concise. -12.02. In the year 2009, what is the difference between the Completion rate(% of total enrollments) in Latin America(developing only) and Completion rate(% of total enrollments) in Pakistan?
Make the answer very short. 37.03. In the year 2009, what is the difference between the Completion rate(% of total enrollments) in Middle East & North Africa (all income levels) and Completion rate(% of total enrollments) in Colombia?
Give a very brief answer. -15.7. In the year 2009, what is the difference between the Completion rate(% of total enrollments) of Middle East & North Africa (all income levels) and Completion rate(% of total enrollments) of Pakistan?
Keep it short and to the point. 33.36. In the year 2009, what is the difference between the Completion rate(% of total enrollments) in Colombia and Completion rate(% of total enrollments) in Pakistan?
Give a very brief answer. 49.06. In the year 2010, what is the difference between the Completion rate(% of total enrollments) of Latin America(developing only) and Completion rate(% of total enrollments) of Middle East & North Africa (all income levels)?
Offer a very short reply. 3.96. In the year 2010, what is the difference between the Completion rate(% of total enrollments) in Latin America(developing only) and Completion rate(% of total enrollments) in Colombia?
Make the answer very short. -14.21. In the year 2010, what is the difference between the Completion rate(% of total enrollments) of Latin America(developing only) and Completion rate(% of total enrollments) of Pakistan?
Provide a short and direct response. 37.78. In the year 2010, what is the difference between the Completion rate(% of total enrollments) in Middle East & North Africa (all income levels) and Completion rate(% of total enrollments) in Colombia?
Offer a very short reply. -18.18. In the year 2010, what is the difference between the Completion rate(% of total enrollments) of Middle East & North Africa (all income levels) and Completion rate(% of total enrollments) of Pakistan?
Your response must be concise. 33.82. In the year 2010, what is the difference between the Completion rate(% of total enrollments) of Colombia and Completion rate(% of total enrollments) of Pakistan?
Your answer should be very brief. 51.99. In the year 2011, what is the difference between the Completion rate(% of total enrollments) of Latin America(developing only) and Completion rate(% of total enrollments) of Middle East & North Africa (all income levels)?
Make the answer very short. 0.74. In the year 2011, what is the difference between the Completion rate(% of total enrollments) of Latin America(developing only) and Completion rate(% of total enrollments) of Colombia?
Give a very brief answer. -13.12. In the year 2011, what is the difference between the Completion rate(% of total enrollments) of Latin America(developing only) and Completion rate(% of total enrollments) of Pakistan?
Your answer should be very brief. 36.86. In the year 2011, what is the difference between the Completion rate(% of total enrollments) of Middle East & North Africa (all income levels) and Completion rate(% of total enrollments) of Colombia?
Offer a terse response. -13.85. In the year 2011, what is the difference between the Completion rate(% of total enrollments) in Middle East & North Africa (all income levels) and Completion rate(% of total enrollments) in Pakistan?
Offer a very short reply. 36.12. In the year 2011, what is the difference between the Completion rate(% of total enrollments) in Colombia and Completion rate(% of total enrollments) in Pakistan?
Make the answer very short. 49.97. In the year 2012, what is the difference between the Completion rate(% of total enrollments) in Latin America(developing only) and Completion rate(% of total enrollments) in Middle East & North Africa (all income levels)?
Provide a short and direct response. -4.5. In the year 2012, what is the difference between the Completion rate(% of total enrollments) in Latin America(developing only) and Completion rate(% of total enrollments) in Colombia?
Your response must be concise. -10.23. In the year 2012, what is the difference between the Completion rate(% of total enrollments) in Latin America(developing only) and Completion rate(% of total enrollments) in Pakistan?
Provide a short and direct response. 32.67. In the year 2012, what is the difference between the Completion rate(% of total enrollments) of Middle East & North Africa (all income levels) and Completion rate(% of total enrollments) of Colombia?
Ensure brevity in your answer.  -5.73. In the year 2012, what is the difference between the Completion rate(% of total enrollments) in Middle East & North Africa (all income levels) and Completion rate(% of total enrollments) in Pakistan?
Ensure brevity in your answer.  37.18. In the year 2012, what is the difference between the Completion rate(% of total enrollments) in Colombia and Completion rate(% of total enrollments) in Pakistan?
Your answer should be very brief. 42.91. What is the ratio of the Completion rate(% of total enrollments) of Latin America(developing only) in 2004 to that in 2005?
Give a very brief answer. 0.98. What is the ratio of the Completion rate(% of total enrollments) of Middle East & North Africa (all income levels) in 2004 to that in 2005?
Your answer should be compact. 0.98. What is the ratio of the Completion rate(% of total enrollments) in Colombia in 2004 to that in 2005?
Your answer should be very brief. 0.93. What is the ratio of the Completion rate(% of total enrollments) of Latin America(developing only) in 2004 to that in 2008?
Make the answer very short. 0.96. What is the ratio of the Completion rate(% of total enrollments) in Colombia in 2004 to that in 2008?
Your answer should be compact. 0.85. What is the ratio of the Completion rate(% of total enrollments) of Pakistan in 2004 to that in 2008?
Offer a very short reply. 0.82. What is the ratio of the Completion rate(% of total enrollments) in Latin America(developing only) in 2004 to that in 2009?
Keep it short and to the point. 0.95. What is the ratio of the Completion rate(% of total enrollments) in Middle East & North Africa (all income levels) in 2004 to that in 2009?
Offer a very short reply. 0.96. What is the ratio of the Completion rate(% of total enrollments) in Colombia in 2004 to that in 2009?
Your answer should be compact. 0.79. What is the ratio of the Completion rate(% of total enrollments) of Pakistan in 2004 to that in 2009?
Offer a terse response. 0.8. What is the ratio of the Completion rate(% of total enrollments) of Latin America(developing only) in 2004 to that in 2010?
Keep it short and to the point. 0.94. What is the ratio of the Completion rate(% of total enrollments) of Middle East & North Africa (all income levels) in 2004 to that in 2010?
Keep it short and to the point. 0.96. What is the ratio of the Completion rate(% of total enrollments) of Colombia in 2004 to that in 2010?
Provide a short and direct response. 0.76. What is the ratio of the Completion rate(% of total enrollments) of Pakistan in 2004 to that in 2010?
Your answer should be very brief. 0.81. What is the ratio of the Completion rate(% of total enrollments) in Latin America(developing only) in 2004 to that in 2011?
Ensure brevity in your answer.  0.95. What is the ratio of the Completion rate(% of total enrollments) in Middle East & North Africa (all income levels) in 2004 to that in 2011?
Your response must be concise. 0.93. What is the ratio of the Completion rate(% of total enrollments) in Colombia in 2004 to that in 2011?
Your response must be concise. 0.78. What is the ratio of the Completion rate(% of total enrollments) of Pakistan in 2004 to that in 2011?
Your response must be concise. 0.81. What is the ratio of the Completion rate(% of total enrollments) of Latin America(developing only) in 2004 to that in 2012?
Provide a short and direct response. 0.96. What is the ratio of the Completion rate(% of total enrollments) in Middle East & North Africa (all income levels) in 2004 to that in 2012?
Offer a very short reply. 0.88. What is the ratio of the Completion rate(% of total enrollments) of Colombia in 2004 to that in 2012?
Give a very brief answer. 0.81. What is the ratio of the Completion rate(% of total enrollments) of Pakistan in 2004 to that in 2012?
Offer a very short reply. 0.74. What is the ratio of the Completion rate(% of total enrollments) in Latin America(developing only) in 2005 to that in 2008?
Keep it short and to the point. 0.98. What is the ratio of the Completion rate(% of total enrollments) in Middle East & North Africa (all income levels) in 2005 to that in 2008?
Your answer should be very brief. 1.01. What is the ratio of the Completion rate(% of total enrollments) of Colombia in 2005 to that in 2008?
Make the answer very short. 0.91. What is the ratio of the Completion rate(% of total enrollments) in Pakistan in 2005 to that in 2008?
Give a very brief answer. 0.84. What is the ratio of the Completion rate(% of total enrollments) in Latin America(developing only) in 2005 to that in 2009?
Provide a succinct answer. 0.97. What is the ratio of the Completion rate(% of total enrollments) of Middle East & North Africa (all income levels) in 2005 to that in 2009?
Ensure brevity in your answer.  0.98. What is the ratio of the Completion rate(% of total enrollments) in Colombia in 2005 to that in 2009?
Provide a short and direct response. 0.85. What is the ratio of the Completion rate(% of total enrollments) in Pakistan in 2005 to that in 2009?
Your answer should be very brief. 0.82. What is the ratio of the Completion rate(% of total enrollments) of Latin America(developing only) in 2005 to that in 2010?
Offer a terse response. 0.96. What is the ratio of the Completion rate(% of total enrollments) in Middle East & North Africa (all income levels) in 2005 to that in 2010?
Offer a very short reply. 0.98. What is the ratio of the Completion rate(% of total enrollments) of Colombia in 2005 to that in 2010?
Make the answer very short. 0.82. What is the ratio of the Completion rate(% of total enrollments) of Pakistan in 2005 to that in 2010?
Make the answer very short. 0.83. What is the ratio of the Completion rate(% of total enrollments) of Latin America(developing only) in 2005 to that in 2011?
Make the answer very short. 0.97. What is the ratio of the Completion rate(% of total enrollments) in Middle East & North Africa (all income levels) in 2005 to that in 2011?
Keep it short and to the point. 0.95. What is the ratio of the Completion rate(% of total enrollments) of Colombia in 2005 to that in 2011?
Your response must be concise. 0.84. What is the ratio of the Completion rate(% of total enrollments) of Pakistan in 2005 to that in 2011?
Provide a succinct answer. 0.82. What is the ratio of the Completion rate(% of total enrollments) of Latin America(developing only) in 2005 to that in 2012?
Your answer should be compact. 0.98. What is the ratio of the Completion rate(% of total enrollments) of Middle East & North Africa (all income levels) in 2005 to that in 2012?
Your answer should be very brief. 0.9. What is the ratio of the Completion rate(% of total enrollments) in Colombia in 2005 to that in 2012?
Ensure brevity in your answer.  0.88. What is the ratio of the Completion rate(% of total enrollments) in Pakistan in 2005 to that in 2012?
Ensure brevity in your answer.  0.76. What is the ratio of the Completion rate(% of total enrollments) in Colombia in 2008 to that in 2009?
Your response must be concise. 0.93. What is the ratio of the Completion rate(% of total enrollments) in Pakistan in 2008 to that in 2009?
Offer a very short reply. 0.97. What is the ratio of the Completion rate(% of total enrollments) in Latin America(developing only) in 2008 to that in 2010?
Provide a short and direct response. 0.99. What is the ratio of the Completion rate(% of total enrollments) in Middle East & North Africa (all income levels) in 2008 to that in 2010?
Your answer should be very brief. 0.97. What is the ratio of the Completion rate(% of total enrollments) in Colombia in 2008 to that in 2010?
Your answer should be very brief. 0.9. What is the ratio of the Completion rate(% of total enrollments) in Pakistan in 2008 to that in 2010?
Offer a terse response. 0.98. What is the ratio of the Completion rate(% of total enrollments) in Middle East & North Africa (all income levels) in 2008 to that in 2011?
Give a very brief answer. 0.94. What is the ratio of the Completion rate(% of total enrollments) of Colombia in 2008 to that in 2011?
Your answer should be very brief. 0.92. What is the ratio of the Completion rate(% of total enrollments) in Pakistan in 2008 to that in 2011?
Provide a short and direct response. 0.98. What is the ratio of the Completion rate(% of total enrollments) in Middle East & North Africa (all income levels) in 2008 to that in 2012?
Keep it short and to the point. 0.88. What is the ratio of the Completion rate(% of total enrollments) of Colombia in 2008 to that in 2012?
Your answer should be very brief. 0.96. What is the ratio of the Completion rate(% of total enrollments) in Pakistan in 2008 to that in 2012?
Keep it short and to the point. 0.9. What is the ratio of the Completion rate(% of total enrollments) in Middle East & North Africa (all income levels) in 2009 to that in 2010?
Make the answer very short. 1. What is the ratio of the Completion rate(% of total enrollments) in Colombia in 2009 to that in 2010?
Offer a very short reply. 0.97. What is the ratio of the Completion rate(% of total enrollments) of Pakistan in 2009 to that in 2010?
Your answer should be very brief. 1.01. What is the ratio of the Completion rate(% of total enrollments) in Latin America(developing only) in 2009 to that in 2011?
Give a very brief answer. 1.01. What is the ratio of the Completion rate(% of total enrollments) of Middle East & North Africa (all income levels) in 2009 to that in 2011?
Make the answer very short. 0.97. What is the ratio of the Completion rate(% of total enrollments) of Colombia in 2009 to that in 2011?
Keep it short and to the point. 0.99. What is the ratio of the Completion rate(% of total enrollments) in Pakistan in 2009 to that in 2011?
Keep it short and to the point. 1.01. What is the ratio of the Completion rate(% of total enrollments) in Latin America(developing only) in 2009 to that in 2012?
Provide a short and direct response. 1.02. What is the ratio of the Completion rate(% of total enrollments) in Middle East & North Africa (all income levels) in 2009 to that in 2012?
Your response must be concise. 0.91. What is the ratio of the Completion rate(% of total enrollments) of Colombia in 2009 to that in 2012?
Your answer should be very brief. 1.03. What is the ratio of the Completion rate(% of total enrollments) in Pakistan in 2009 to that in 2012?
Your answer should be compact. 0.93. What is the ratio of the Completion rate(% of total enrollments) of Latin America(developing only) in 2010 to that in 2011?
Offer a very short reply. 1.01. What is the ratio of the Completion rate(% of total enrollments) in Middle East & North Africa (all income levels) in 2010 to that in 2011?
Your response must be concise. 0.97. What is the ratio of the Completion rate(% of total enrollments) of Colombia in 2010 to that in 2011?
Ensure brevity in your answer.  1.02. What is the ratio of the Completion rate(% of total enrollments) of Pakistan in 2010 to that in 2011?
Offer a terse response. 1. What is the ratio of the Completion rate(% of total enrollments) of Latin America(developing only) in 2010 to that in 2012?
Make the answer very short. 1.02. What is the ratio of the Completion rate(% of total enrollments) in Middle East & North Africa (all income levels) in 2010 to that in 2012?
Make the answer very short. 0.91. What is the ratio of the Completion rate(% of total enrollments) of Colombia in 2010 to that in 2012?
Your response must be concise. 1.06. What is the ratio of the Completion rate(% of total enrollments) in Pakistan in 2010 to that in 2012?
Offer a very short reply. 0.92. What is the ratio of the Completion rate(% of total enrollments) of Latin America(developing only) in 2011 to that in 2012?
Keep it short and to the point. 1.01. What is the ratio of the Completion rate(% of total enrollments) of Middle East & North Africa (all income levels) in 2011 to that in 2012?
Provide a succinct answer. 0.94. What is the ratio of the Completion rate(% of total enrollments) in Colombia in 2011 to that in 2012?
Offer a terse response. 1.04. What is the ratio of the Completion rate(% of total enrollments) in Pakistan in 2011 to that in 2012?
Make the answer very short. 0.92. What is the difference between the highest and the second highest Completion rate(% of total enrollments) in Latin America(developing only)?
Your answer should be compact. 0.3. What is the difference between the highest and the second highest Completion rate(% of total enrollments) of Middle East & North Africa (all income levels)?
Your answer should be compact. 4.51. What is the difference between the highest and the second highest Completion rate(% of total enrollments) of Colombia?
Provide a short and direct response. 1.88. What is the difference between the highest and the second highest Completion rate(% of total enrollments) of Pakistan?
Provide a short and direct response. 3.15. What is the difference between the highest and the lowest Completion rate(% of total enrollments) of Latin America(developing only)?
Keep it short and to the point. 4.39. What is the difference between the highest and the lowest Completion rate(% of total enrollments) of Middle East & North Africa (all income levels)?
Provide a short and direct response. 9.66. What is the difference between the highest and the lowest Completion rate(% of total enrollments) of Colombia?
Your answer should be very brief. 21.48. What is the difference between the highest and the lowest Completion rate(% of total enrollments) of Pakistan?
Give a very brief answer. 11.08. 